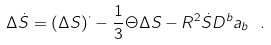Convert formula to latex. <formula><loc_0><loc_0><loc_500><loc_500>\Delta \dot { S } = \left ( \Delta S \right ) ^ { \cdot } - { \frac { 1 } { 3 } } \Theta \Delta S - R ^ { 2 } \dot { S } D ^ { b } a _ { b } \ .</formula> 